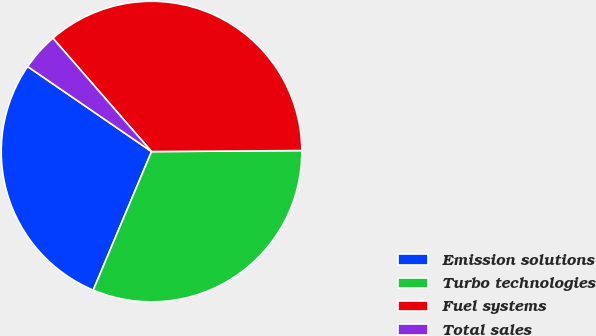Convert chart. <chart><loc_0><loc_0><loc_500><loc_500><pie_chart><fcel>Emission solutions<fcel>Turbo technologies<fcel>Fuel systems<fcel>Total sales<nl><fcel>28.23%<fcel>31.45%<fcel>36.29%<fcel>4.03%<nl></chart> 